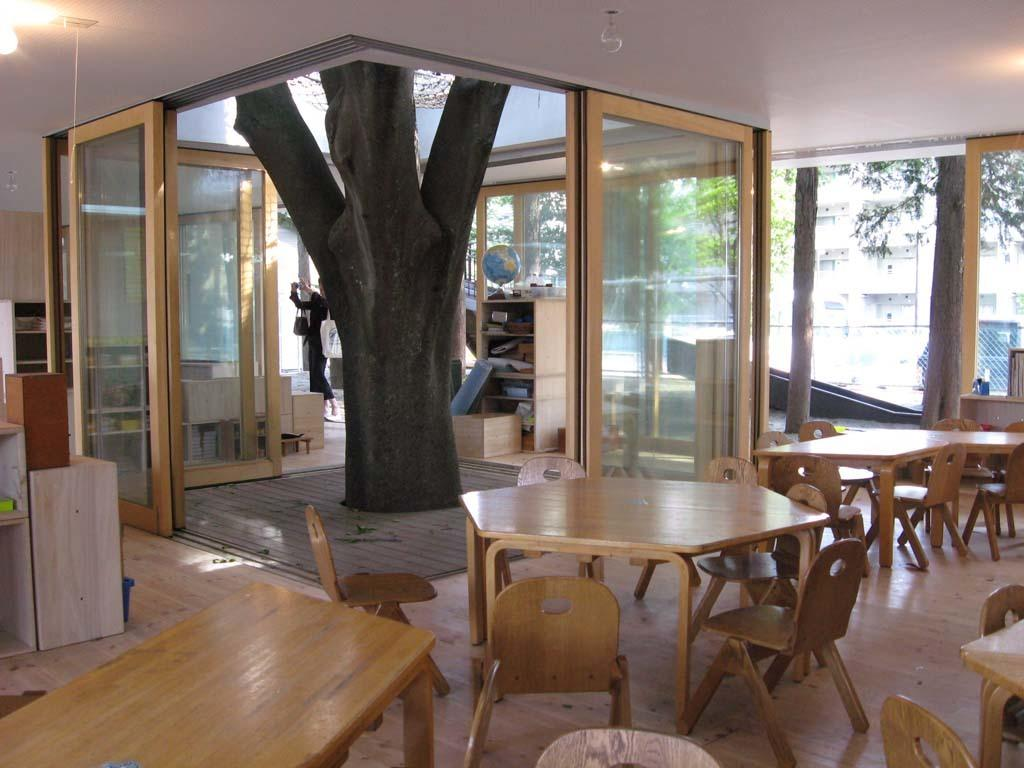What type of furniture can be seen in the image? There are tables and chairs in the image. What architectural features are present in the image? There are doors and a cupboard in the image. What type of natural elements are visible in the image? There are trees in the image. What type of man-made structures are visible in the image? There are buildings in the image. What type of establishment is the image taken in? The image is taken in a hotel. Where is the secretary sitting in the image? There is no secretary present in the image. What type of road can be seen in the image? There is no road visible in the image. 